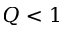<formula> <loc_0><loc_0><loc_500><loc_500>Q < 1</formula> 